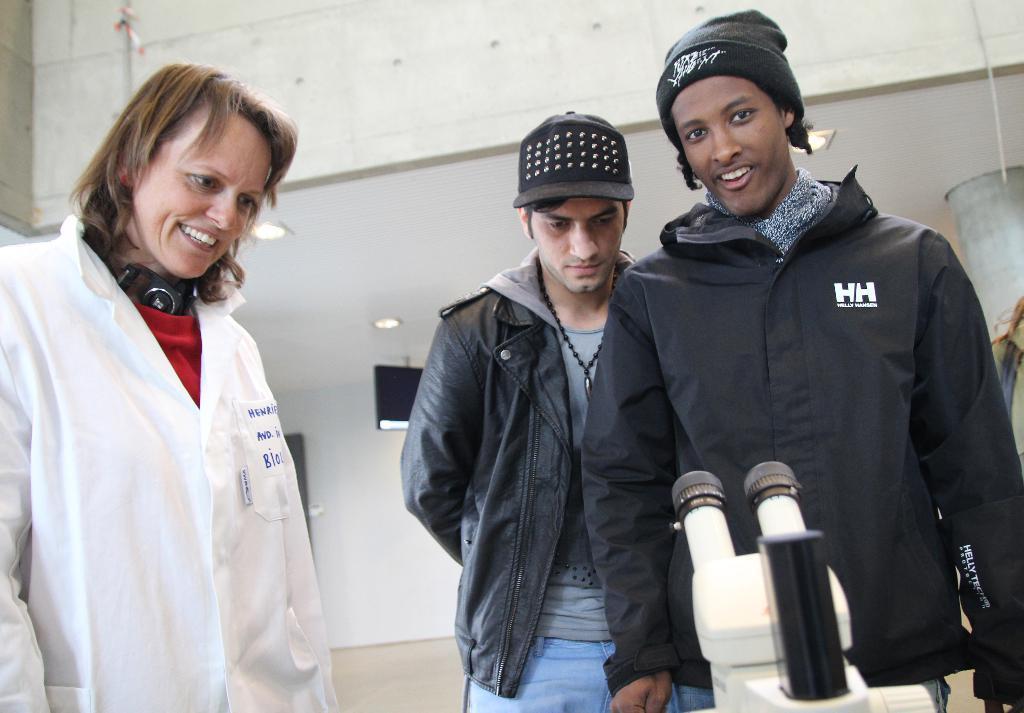Could you give a brief overview of what you see in this image? This picture describes about group of people, few people wore caps, in front of them we can see a microscope, in the background we can see few lights and a screen. 